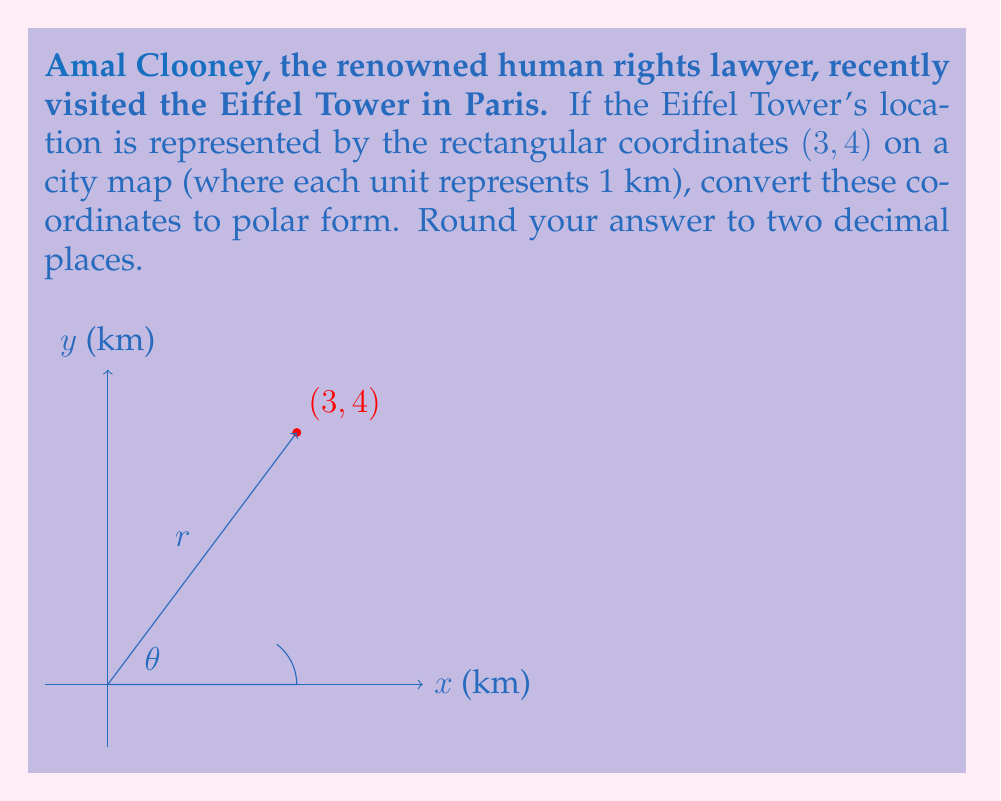What is the answer to this math problem? To convert rectangular coordinates $(x, y)$ to polar coordinates $(r, \theta)$, we use the following formulas:

1. $r = \sqrt{x^2 + y^2}$
2. $\theta = \tan^{-1}(\frac{y}{x})$

For the Eiffel Tower's location (3, 4):

1. Calculate $r$:
   $$r = \sqrt{3^2 + 4^2} = \sqrt{9 + 16} = \sqrt{25} = 5$$

2. Calculate $\theta$:
   $$\theta = \tan^{-1}(\frac{4}{3}) \approx 0.9273 \text{ radians}$$

3. Convert radians to degrees:
   $$0.9273 \text{ radians} \times \frac{180°}{\pi} \approx 53.13°$$

Therefore, the polar coordinates are $(5, 53.13°)$.

Note: The angle is in the first quadrant because both $x$ and $y$ are positive.
Answer: $(5, 53.13°)$ 